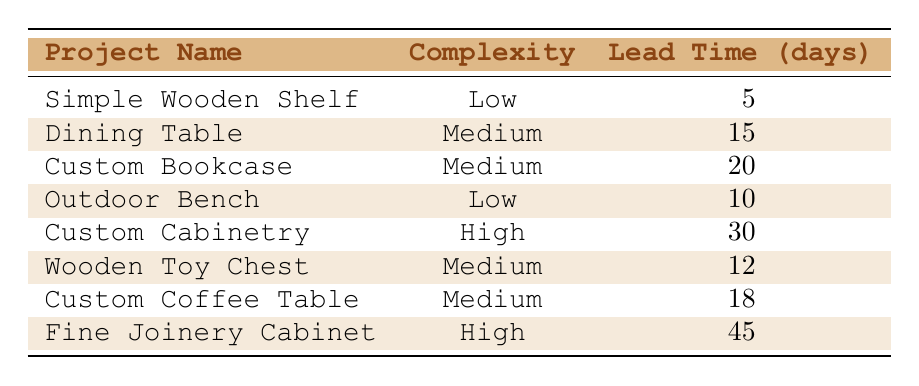What is the average lead time for low complexity projects? The low complexity projects are "Simple Wooden Shelf" (5 days) and "Outdoor Bench" (10 days). Adding these gives 5 + 10 = 15 days. To find the average, divide by the number of projects (2): 15 / 2 = 7.5 days.
Answer: 7.5 days Which project has the longest lead time? The project with the longest lead time is "Fine Joinery Cabinet," which takes 45 days.
Answer: Fine Joinery Cabinet How many medium complexity projects are listed? There are four medium complexity projects: "Dining Table," "Custom Bookcase," "Wooden Toy Chest," and "Custom Coffee Table."
Answer: 4 What is the total lead time for all projects? The total lead time is calculated by adding all individual lead times: 5 + 15 + 20 + 10 + 30 + 12 + 18 + 45 = 155 days.
Answer: 155 days Is the lead time for "Custom Cabinetry" greater than the average lead time for medium complexity projects? The average lead time for medium complexity projects is (15 + 20 + 12 + 18) / 4 = 15.25 days. Since "Custom Cabinetry" has a lead time of 30 days, which is greater than 15.25 days, the answer is yes.
Answer: Yes What is the difference in lead time between the most and least complex projects? The highest lead time is for "Fine Joinery Cabinet" at 45 days, and the lowest is for "Simple Wooden Shelf" at 5 days. The difference is 45 - 5 = 40 days.
Answer: 40 days Which materials are needed for a "Custom Coffee Table"? The materials required for a "Custom Coffee Table" include Walnut wood, Glass top, and Finish.
Answer: Walnut wood, Glass top, Finish How many projects have a lead time of 20 days or more? The projects with a lead time of 20 days or more are "Custom Bookcase" (20 days), "Custom Cabinetry" (30 days), and "Fine Joinery Cabinet" (45 days). That makes three projects.
Answer: 3 If a project takes double the lead time of the "Simple Wooden Shelf," what would that lead time be? The lead time for the "Simple Wooden Shelf" is 5 days, so double that is 5 * 2 = 10 days.
Answer: 10 days What is the median lead time of all projects? To find the median, first list the lead times in order: 5, 10, 12, 15, 18, 20, 30, 45. There are 8 lead times, so the median is the average of the 4th and 5th values: (15 + 18) / 2 = 16.5 days.
Answer: 16.5 days Are there any projects with a lead time of less than 10 days? The only project with a lead time of less than 10 days is "Simple Wooden Shelf," which takes 5 days.
Answer: Yes 